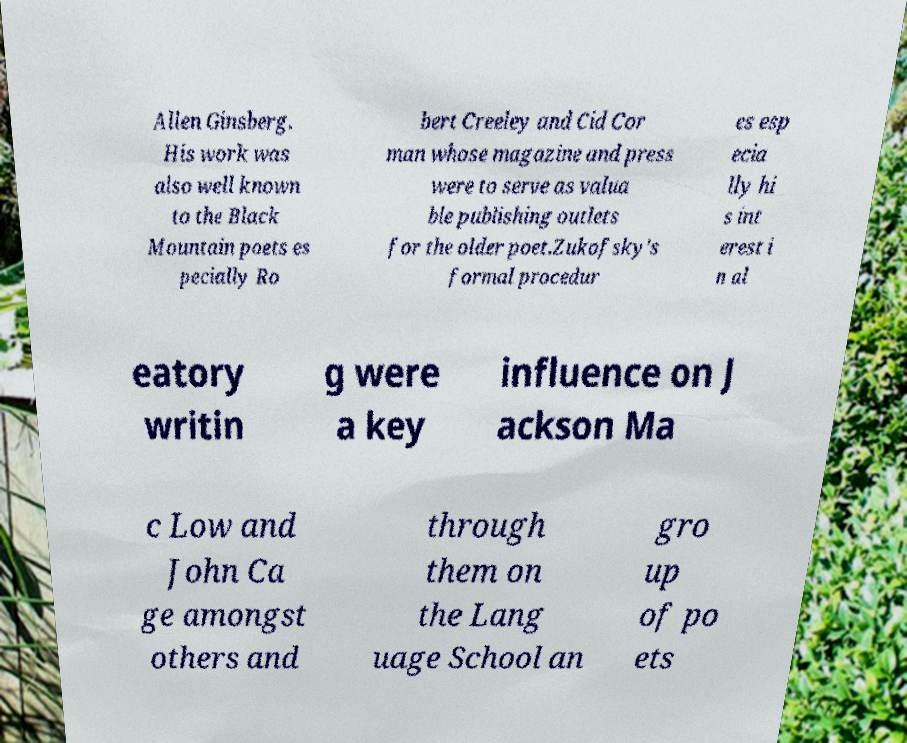For documentation purposes, I need the text within this image transcribed. Could you provide that? Allen Ginsberg. His work was also well known to the Black Mountain poets es pecially Ro bert Creeley and Cid Cor man whose magazine and press were to serve as valua ble publishing outlets for the older poet.Zukofsky's formal procedur es esp ecia lly hi s int erest i n al eatory writin g were a key influence on J ackson Ma c Low and John Ca ge amongst others and through them on the Lang uage School an gro up of po ets 